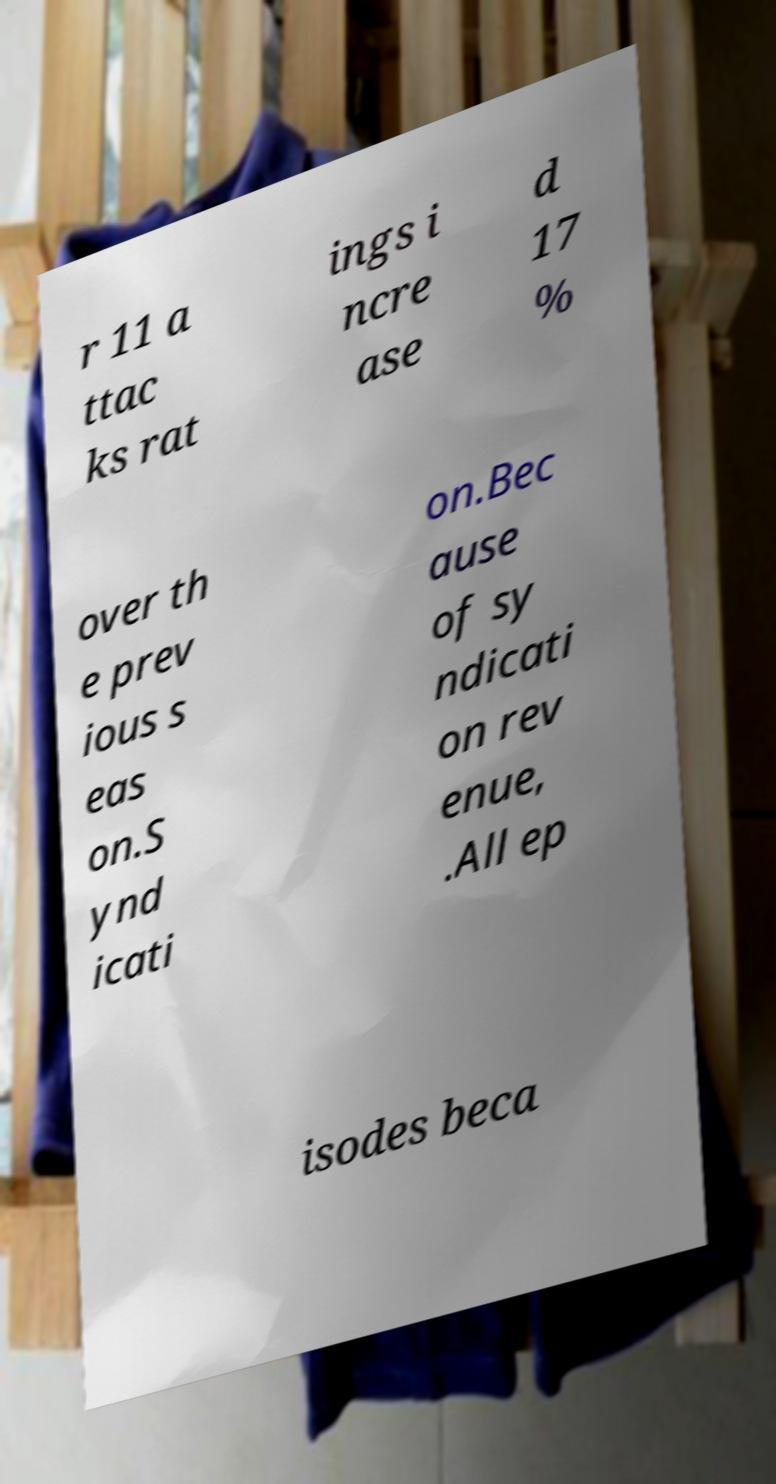Can you accurately transcribe the text from the provided image for me? r 11 a ttac ks rat ings i ncre ase d 17 % over th e prev ious s eas on.S ynd icati on.Bec ause of sy ndicati on rev enue, .All ep isodes beca 